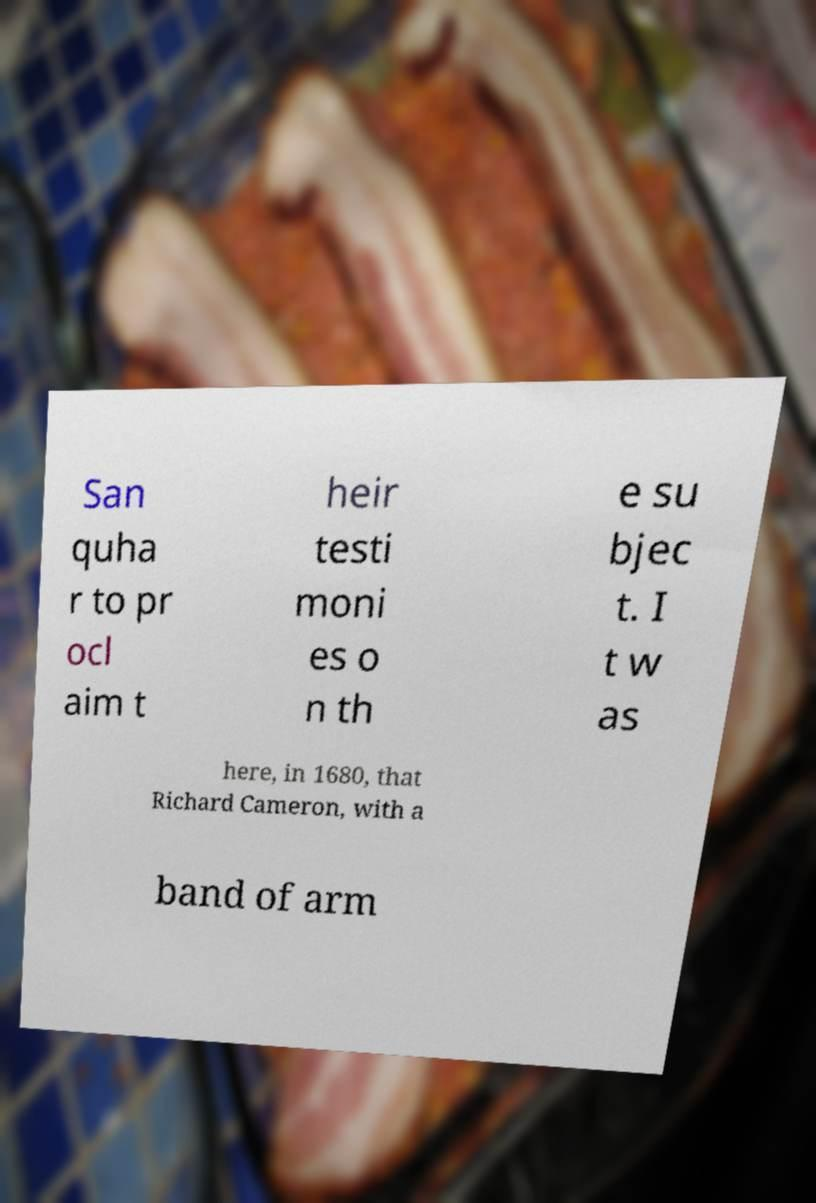I need the written content from this picture converted into text. Can you do that? San quha r to pr ocl aim t heir testi moni es o n th e su bjec t. I t w as here, in 1680, that Richard Cameron, with a band of arm 